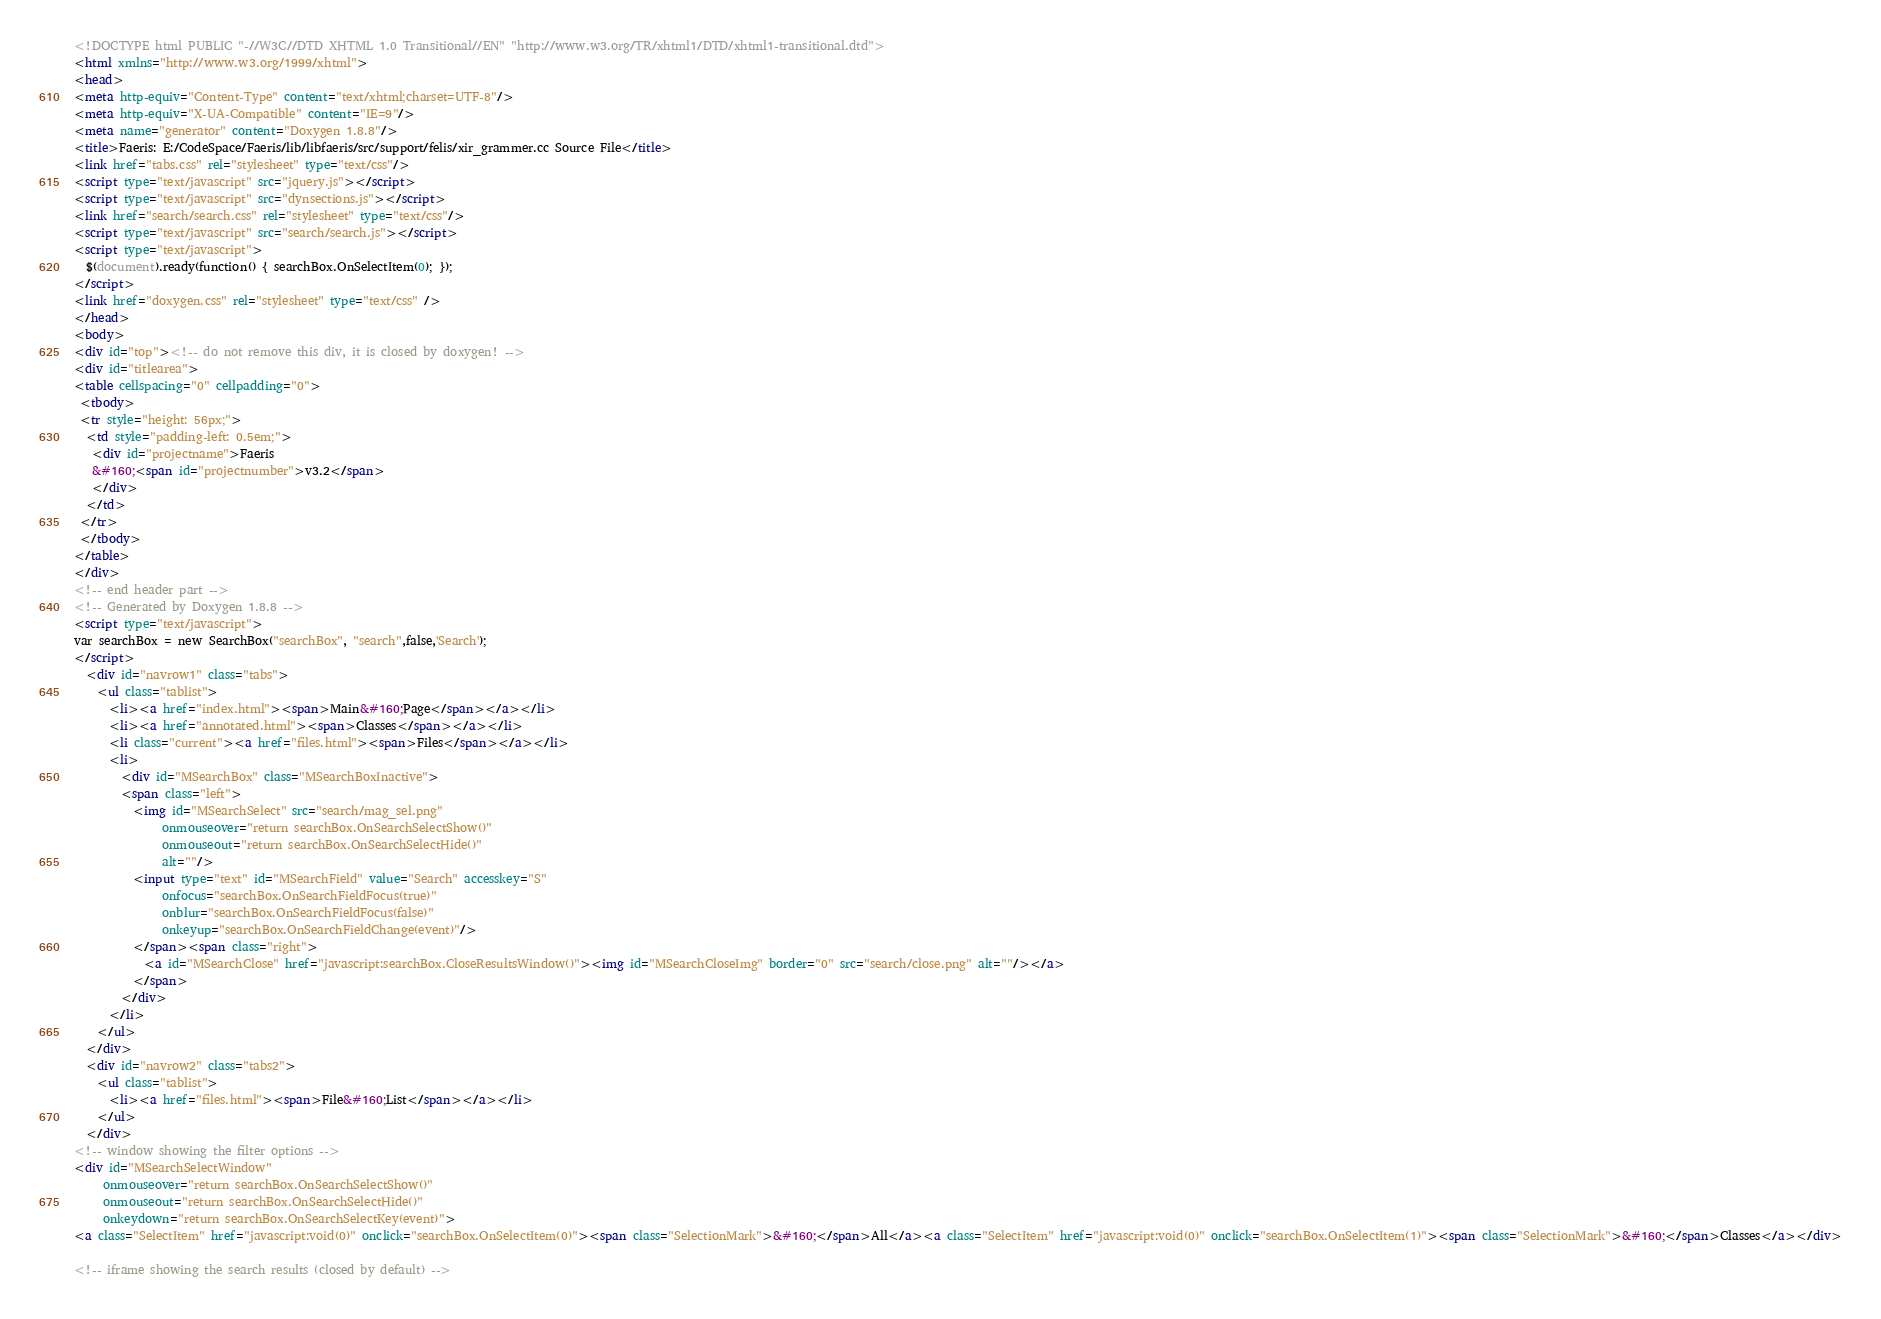<code> <loc_0><loc_0><loc_500><loc_500><_HTML_><!DOCTYPE html PUBLIC "-//W3C//DTD XHTML 1.0 Transitional//EN" "http://www.w3.org/TR/xhtml1/DTD/xhtml1-transitional.dtd">
<html xmlns="http://www.w3.org/1999/xhtml">
<head>
<meta http-equiv="Content-Type" content="text/xhtml;charset=UTF-8"/>
<meta http-equiv="X-UA-Compatible" content="IE=9"/>
<meta name="generator" content="Doxygen 1.8.8"/>
<title>Faeris: E:/CodeSpace/Faeris/lib/libfaeris/src/support/felis/xir_grammer.cc Source File</title>
<link href="tabs.css" rel="stylesheet" type="text/css"/>
<script type="text/javascript" src="jquery.js"></script>
<script type="text/javascript" src="dynsections.js"></script>
<link href="search/search.css" rel="stylesheet" type="text/css"/>
<script type="text/javascript" src="search/search.js"></script>
<script type="text/javascript">
  $(document).ready(function() { searchBox.OnSelectItem(0); });
</script>
<link href="doxygen.css" rel="stylesheet" type="text/css" />
</head>
<body>
<div id="top"><!-- do not remove this div, it is closed by doxygen! -->
<div id="titlearea">
<table cellspacing="0" cellpadding="0">
 <tbody>
 <tr style="height: 56px;">
  <td style="padding-left: 0.5em;">
   <div id="projectname">Faeris
   &#160;<span id="projectnumber">v3.2</span>
   </div>
  </td>
 </tr>
 </tbody>
</table>
</div>
<!-- end header part -->
<!-- Generated by Doxygen 1.8.8 -->
<script type="text/javascript">
var searchBox = new SearchBox("searchBox", "search",false,'Search');
</script>
  <div id="navrow1" class="tabs">
    <ul class="tablist">
      <li><a href="index.html"><span>Main&#160;Page</span></a></li>
      <li><a href="annotated.html"><span>Classes</span></a></li>
      <li class="current"><a href="files.html"><span>Files</span></a></li>
      <li>
        <div id="MSearchBox" class="MSearchBoxInactive">
        <span class="left">
          <img id="MSearchSelect" src="search/mag_sel.png"
               onmouseover="return searchBox.OnSearchSelectShow()"
               onmouseout="return searchBox.OnSearchSelectHide()"
               alt=""/>
          <input type="text" id="MSearchField" value="Search" accesskey="S"
               onfocus="searchBox.OnSearchFieldFocus(true)" 
               onblur="searchBox.OnSearchFieldFocus(false)" 
               onkeyup="searchBox.OnSearchFieldChange(event)"/>
          </span><span class="right">
            <a id="MSearchClose" href="javascript:searchBox.CloseResultsWindow()"><img id="MSearchCloseImg" border="0" src="search/close.png" alt=""/></a>
          </span>
        </div>
      </li>
    </ul>
  </div>
  <div id="navrow2" class="tabs2">
    <ul class="tablist">
      <li><a href="files.html"><span>File&#160;List</span></a></li>
    </ul>
  </div>
<!-- window showing the filter options -->
<div id="MSearchSelectWindow"
     onmouseover="return searchBox.OnSearchSelectShow()"
     onmouseout="return searchBox.OnSearchSelectHide()"
     onkeydown="return searchBox.OnSearchSelectKey(event)">
<a class="SelectItem" href="javascript:void(0)" onclick="searchBox.OnSelectItem(0)"><span class="SelectionMark">&#160;</span>All</a><a class="SelectItem" href="javascript:void(0)" onclick="searchBox.OnSelectItem(1)"><span class="SelectionMark">&#160;</span>Classes</a></div>

<!-- iframe showing the search results (closed by default) --></code> 